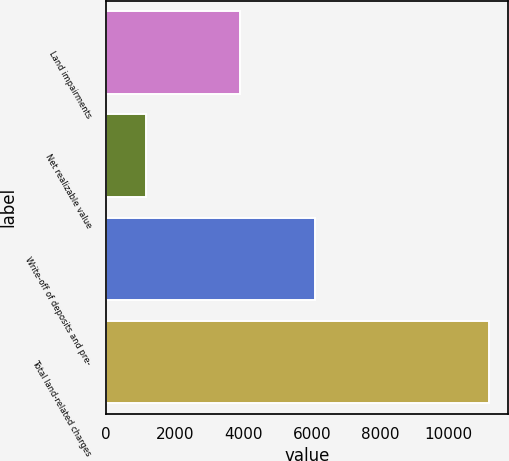<chart> <loc_0><loc_0><loc_500><loc_500><bar_chart><fcel>Land impairments<fcel>Net realizable value<fcel>Write-off of deposits and pre-<fcel>Total land-related charges<nl><fcel>3911<fcel>1158<fcel>6099<fcel>11168<nl></chart> 